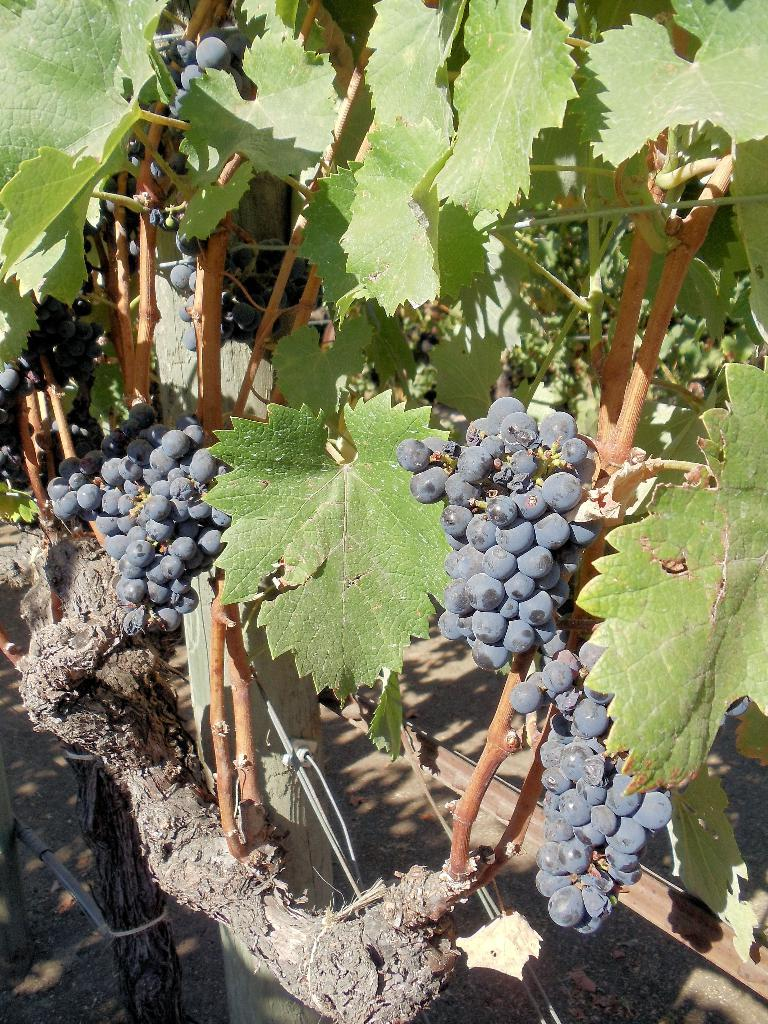What type of plant is in the image? The plant in the image has grape fruits and leaves. What can be found on the plant besides leaves? The plant has grape fruits. How does the plant use the cheese to grow in the image? There is no cheese present in the image, and therefore it cannot be used by the plant to grow. 